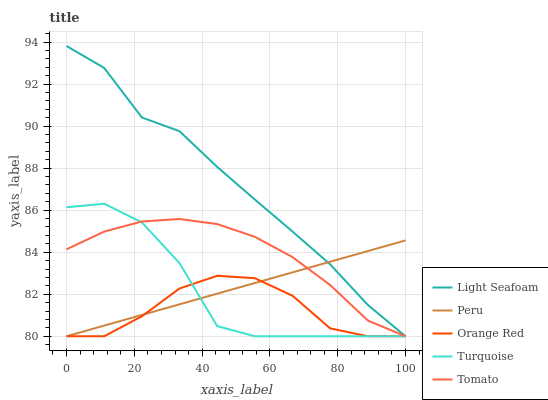Does Orange Red have the minimum area under the curve?
Answer yes or no. Yes. Does Light Seafoam have the maximum area under the curve?
Answer yes or no. Yes. Does Turquoise have the minimum area under the curve?
Answer yes or no. No. Does Turquoise have the maximum area under the curve?
Answer yes or no. No. Is Peru the smoothest?
Answer yes or no. Yes. Is Turquoise the roughest?
Answer yes or no. Yes. Is Light Seafoam the smoothest?
Answer yes or no. No. Is Light Seafoam the roughest?
Answer yes or no. No. Does Tomato have the lowest value?
Answer yes or no. Yes. Does Light Seafoam have the highest value?
Answer yes or no. Yes. Does Turquoise have the highest value?
Answer yes or no. No. Does Turquoise intersect Peru?
Answer yes or no. Yes. Is Turquoise less than Peru?
Answer yes or no. No. Is Turquoise greater than Peru?
Answer yes or no. No. 